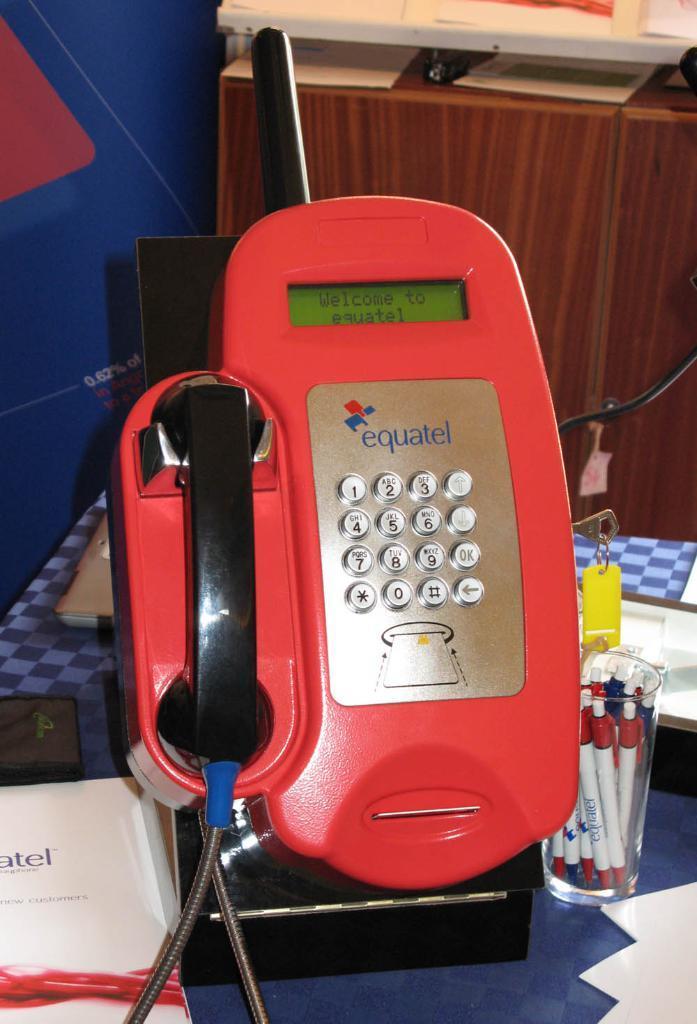Can you describe this image briefly? In this image I can see a red and black colour telephone in the centre. On the right side of this image I can see a key, a yellow colour keychain, a glass, few white colour things and in the glass I can see number of pens. On the left side of this image I can see a book and on it I can see something is written. In the background I can see a cupboard and on the top of it I can see a white colour thing. 